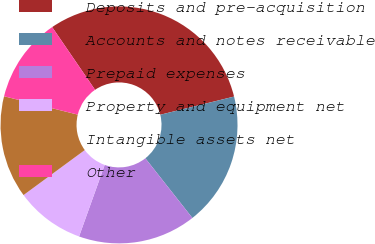Convert chart to OTSL. <chart><loc_0><loc_0><loc_500><loc_500><pie_chart><fcel>Deposits and pre-acquisition<fcel>Accounts and notes receivable<fcel>Prepaid expenses<fcel>Property and equipment net<fcel>Intangible assets net<fcel>Other<nl><fcel>30.7%<fcel>18.22%<fcel>16.1%<fcel>9.44%<fcel>13.97%<fcel>11.57%<nl></chart> 